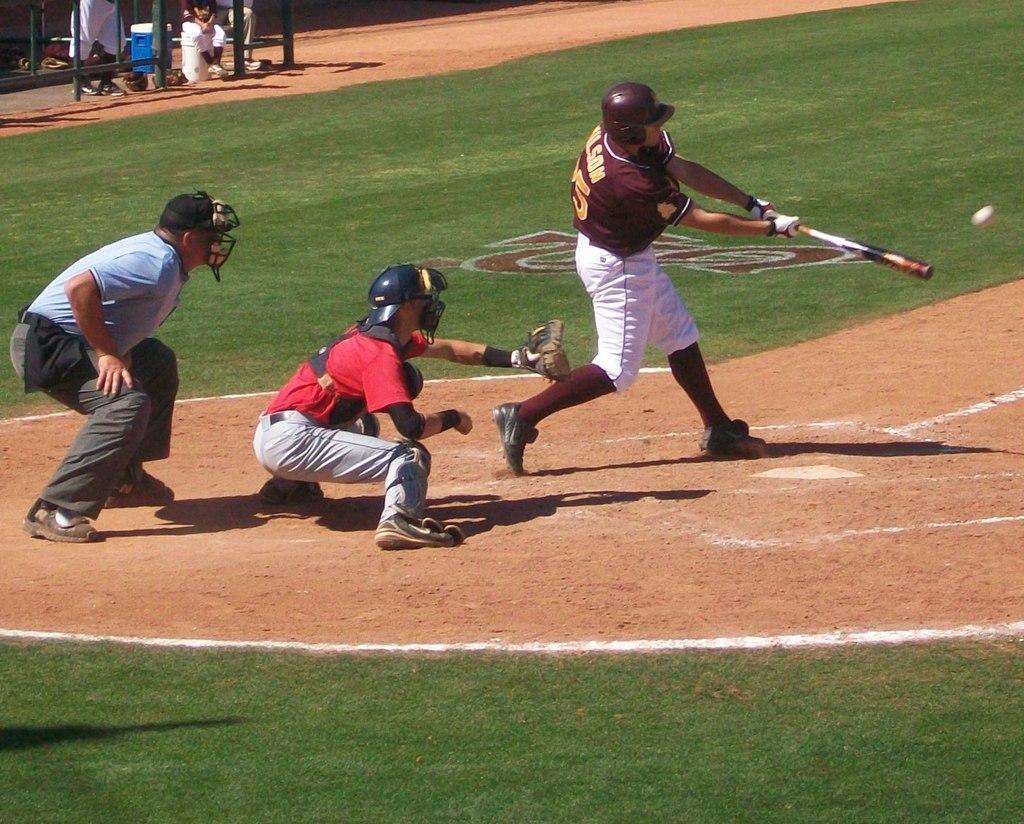Please provide a concise description of this image. In this image we can see group of people standing on the ground. One person is wearing a baseball uniform and holding a baseball bat in his hand. One person wearing red t shirt is wearing a gloves. In the background we can see group of persons,containers and a metal gate. 